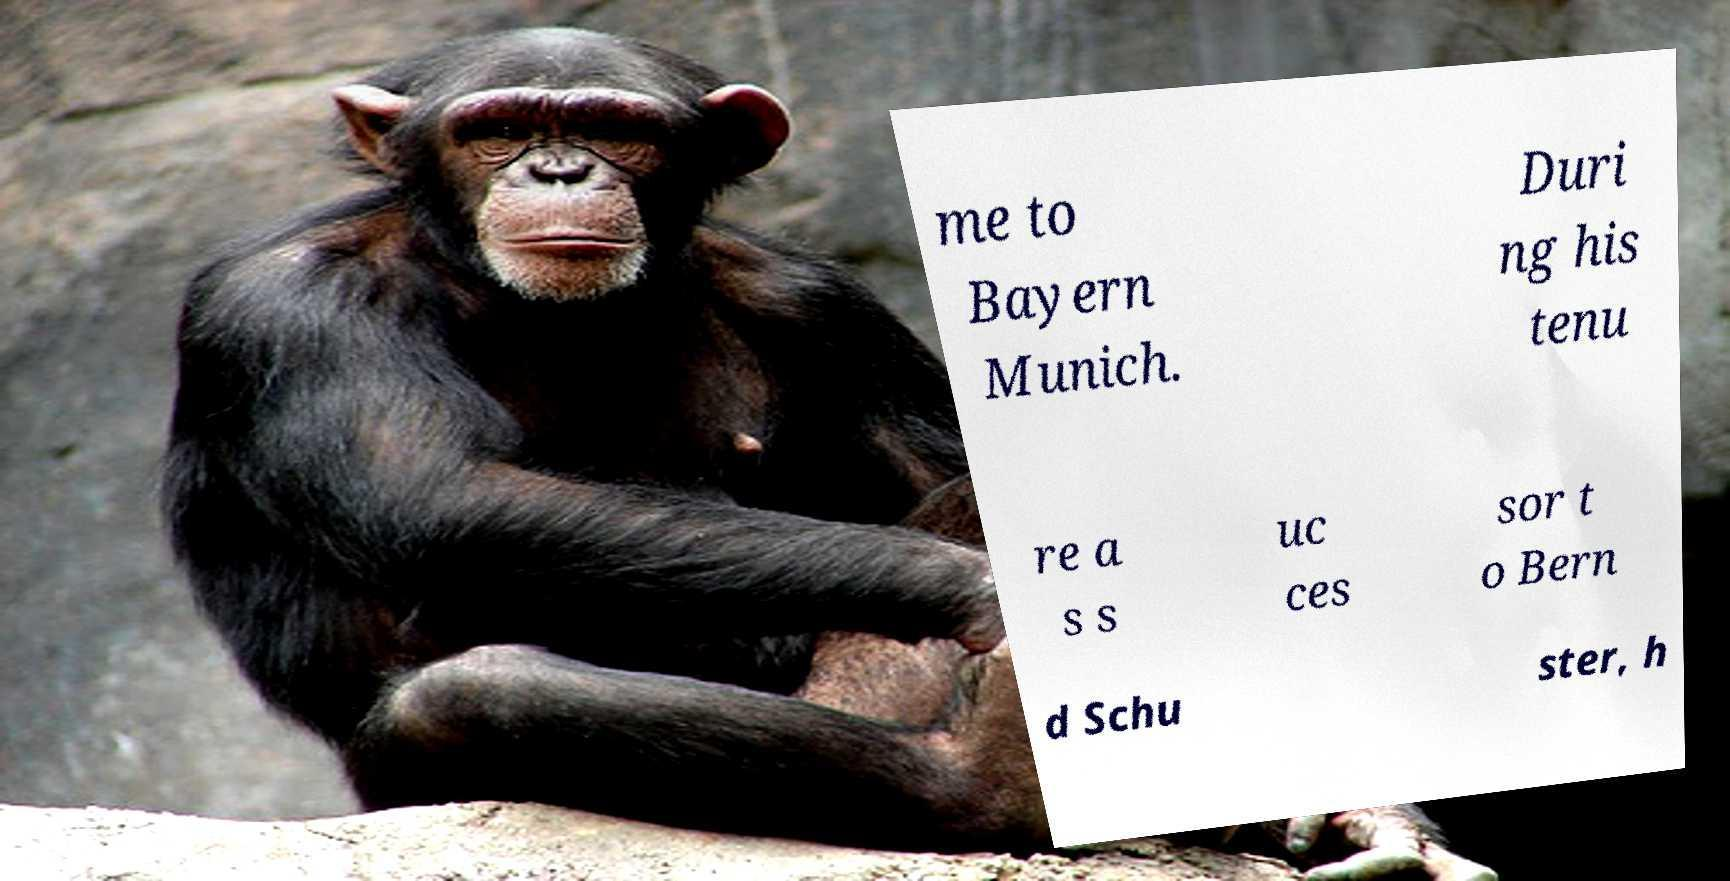I need the written content from this picture converted into text. Can you do that? me to Bayern Munich. Duri ng his tenu re a s s uc ces sor t o Bern d Schu ster, h 